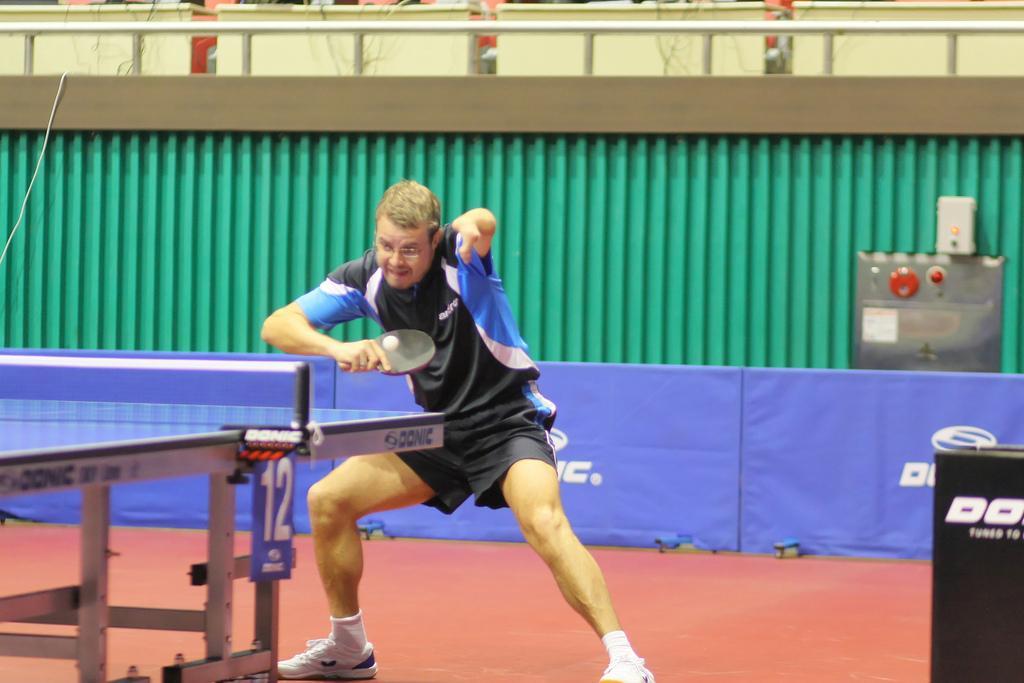Could you give a brief overview of what you see in this image? Man in black and blue t-shirt is playing table tennis. Behind him, we see blue boards and behind that, we see green wall and on the right bottom of the picture, we see black color box. 